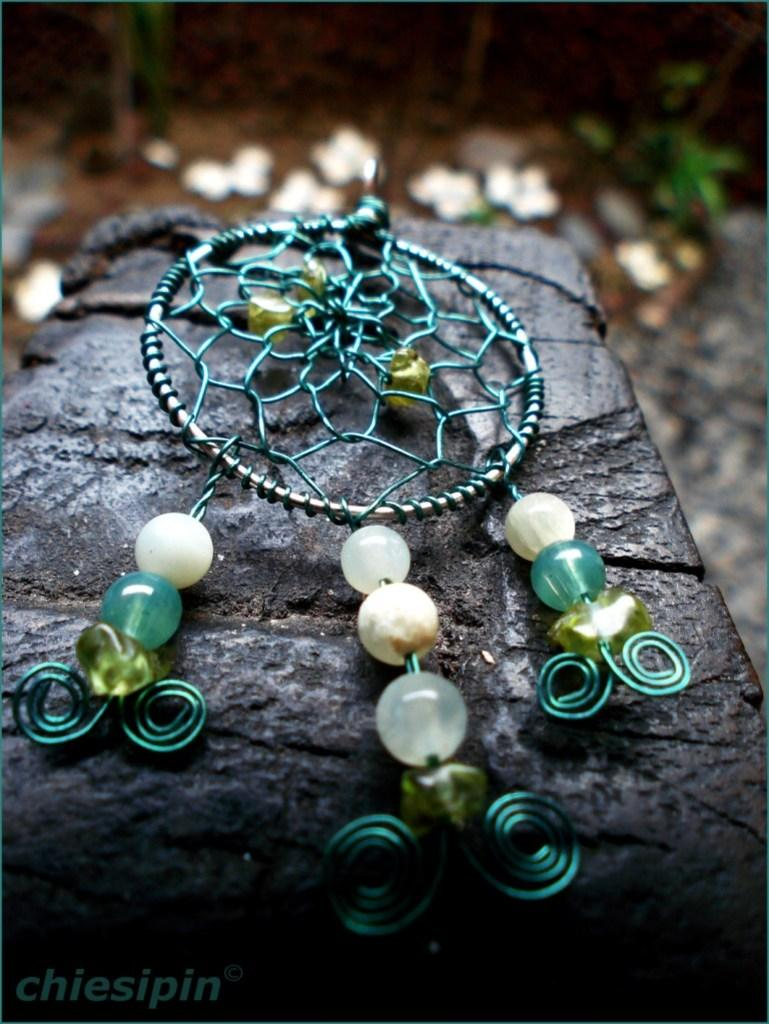What is hanging in the image? There is a hanging showpiece in the image. What can be seen on the right side of the image? There is a plant on the right side of the image. How would you describe the background of the image? The background of the image is blurry. Where is the text located in the image? The text is at the left bottom of the image. Reasoning: Let'g: Let's think step by step in order to produce the conversation. We start by identifying the main subjects and objects in the image based on the provided facts. We then formulate questions that focus on the location and characteristics of these subjects and objects, ensuring that each question can be answered definitively with the information given. We avoid yes/no questions and ensure that the language is simple and clear. Absurd Question/Answer: What type of camera is being used to take the picture of the hanging showpiece? There is no information about a camera being used to take the picture, as the focus is on the objects and subjects in the image. What channel is the plant on the right side of the image tuned to? The image does not depict a television or any channel; it features a plant and a hanging showpiece. What type of yam is being used as a prop for the hanging showpiece? There is no yam present in the image, and the hanging showpiece is not supported by any prop. 